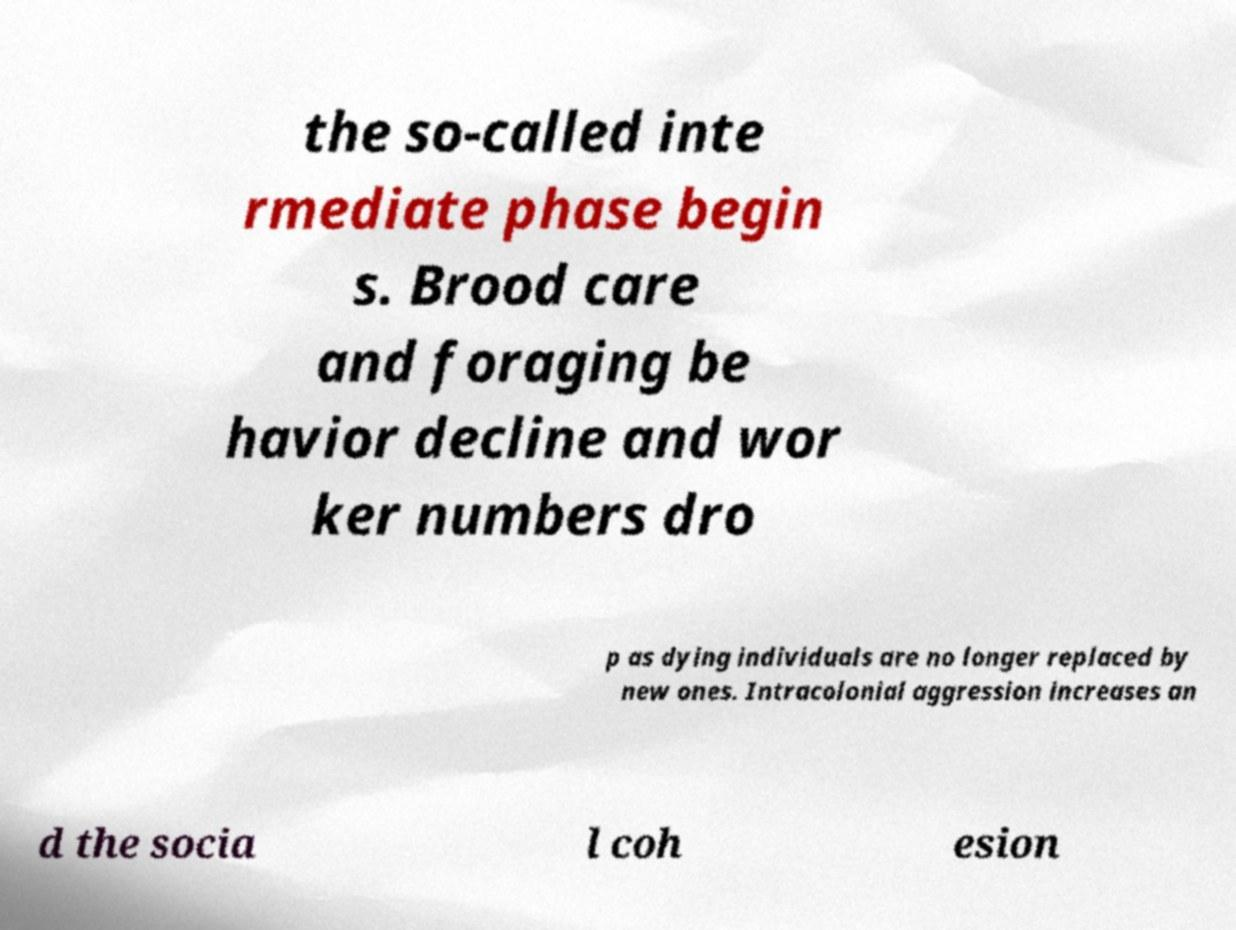Could you assist in decoding the text presented in this image and type it out clearly? the so-called inte rmediate phase begin s. Brood care and foraging be havior decline and wor ker numbers dro p as dying individuals are no longer replaced by new ones. Intracolonial aggression increases an d the socia l coh esion 